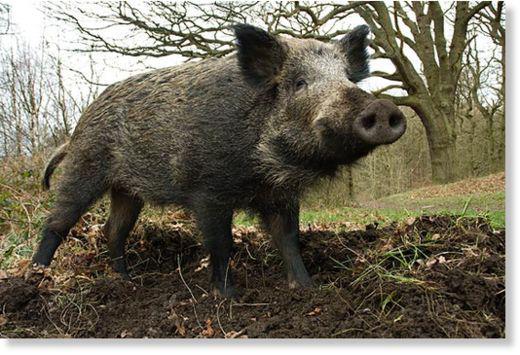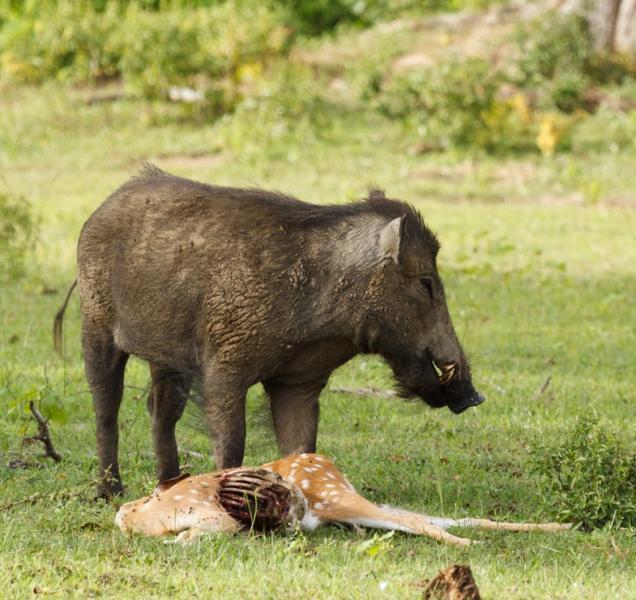The first image is the image on the left, the second image is the image on the right. Evaluate the accuracy of this statement regarding the images: "An image shows one boar standing over the dead body of a hooved animal.". Is it true? Answer yes or no. Yes. The first image is the image on the left, the second image is the image on the right. Considering the images on both sides, is "There are at least two boars in the left image." valid? Answer yes or no. No. 